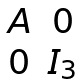<formula> <loc_0><loc_0><loc_500><loc_500>\begin{matrix} A & 0 \\ 0 & I _ { 3 } \end{matrix}</formula> 